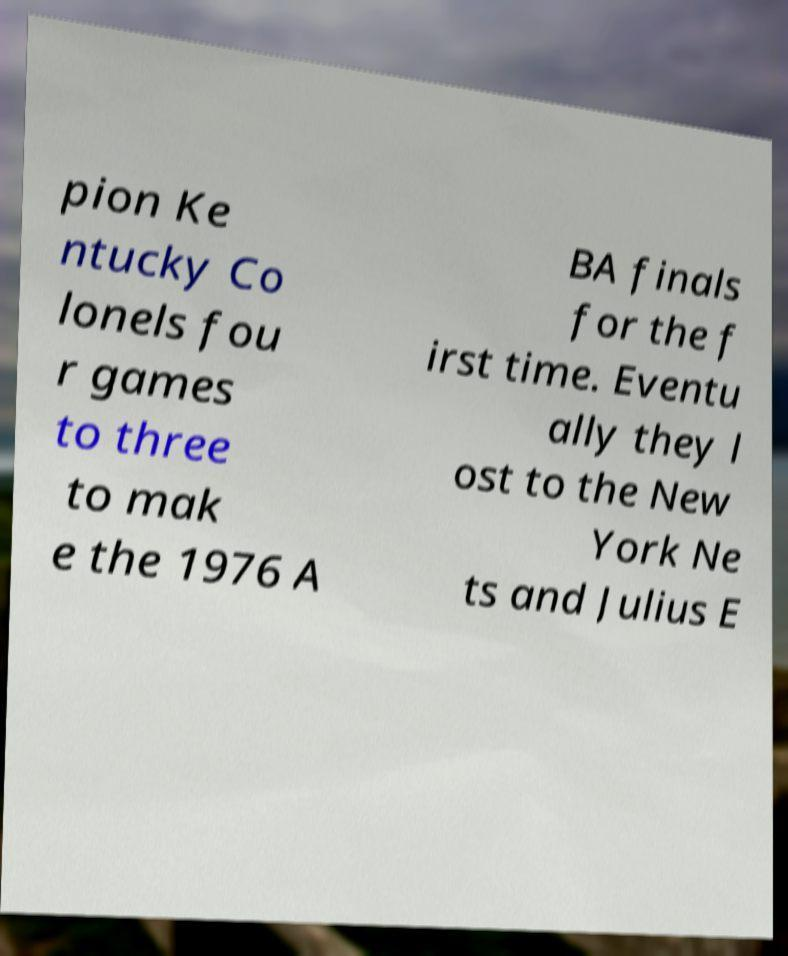Can you accurately transcribe the text from the provided image for me? pion Ke ntucky Co lonels fou r games to three to mak e the 1976 A BA finals for the f irst time. Eventu ally they l ost to the New York Ne ts and Julius E 